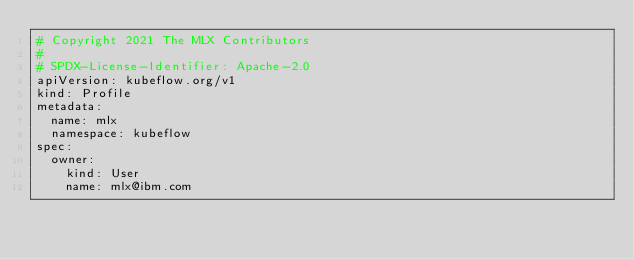Convert code to text. <code><loc_0><loc_0><loc_500><loc_500><_YAML_># Copyright 2021 The MLX Contributors
#
# SPDX-License-Identifier: Apache-2.0
apiVersion: kubeflow.org/v1
kind: Profile
metadata:
  name: mlx
  namespace: kubeflow
spec:
  owner:
    kind: User
    name: mlx@ibm.com
</code> 